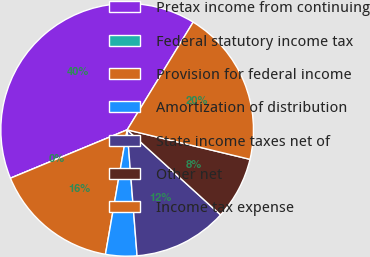<chart> <loc_0><loc_0><loc_500><loc_500><pie_chart><fcel>Pretax income from continuing<fcel>Federal statutory income tax<fcel>Provision for federal income<fcel>Amortization of distribution<fcel>State income taxes net of<fcel>Other net<fcel>Income tax expense<nl><fcel>40.0%<fcel>0.0%<fcel>16.0%<fcel>4.0%<fcel>12.0%<fcel>8.0%<fcel>20.0%<nl></chart> 